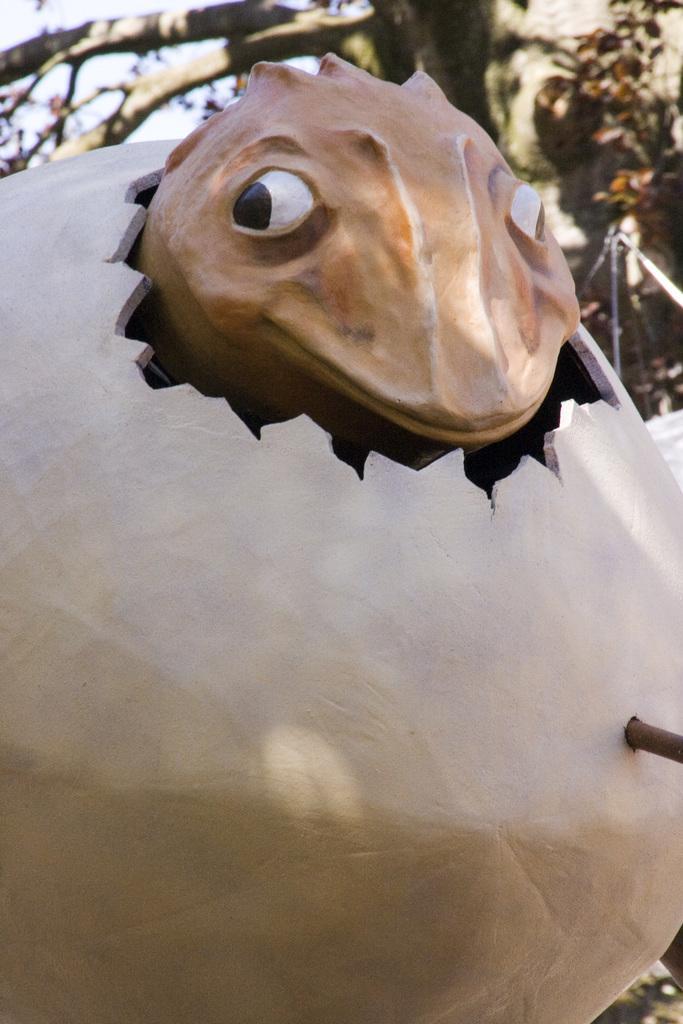How would you summarize this image in a sentence or two? In this image there is a sculpture of a dragon egg, inside the egg there is a dragon, in the background there is a tree. 